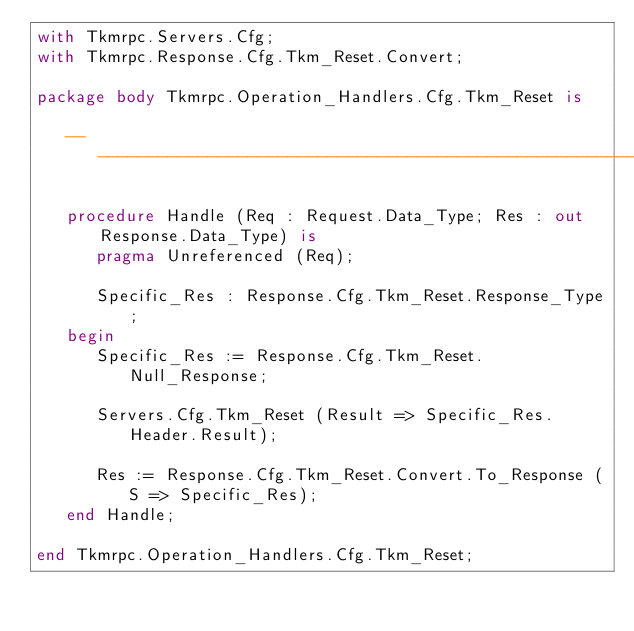Convert code to text. <code><loc_0><loc_0><loc_500><loc_500><_Ada_>with Tkmrpc.Servers.Cfg;
with Tkmrpc.Response.Cfg.Tkm_Reset.Convert;

package body Tkmrpc.Operation_Handlers.Cfg.Tkm_Reset is

   -------------------------------------------------------------------------

   procedure Handle (Req : Request.Data_Type; Res : out Response.Data_Type) is
      pragma Unreferenced (Req);

      Specific_Res : Response.Cfg.Tkm_Reset.Response_Type;
   begin
      Specific_Res := Response.Cfg.Tkm_Reset.Null_Response;

      Servers.Cfg.Tkm_Reset (Result => Specific_Res.Header.Result);

      Res := Response.Cfg.Tkm_Reset.Convert.To_Response (S => Specific_Res);
   end Handle;

end Tkmrpc.Operation_Handlers.Cfg.Tkm_Reset;
</code> 